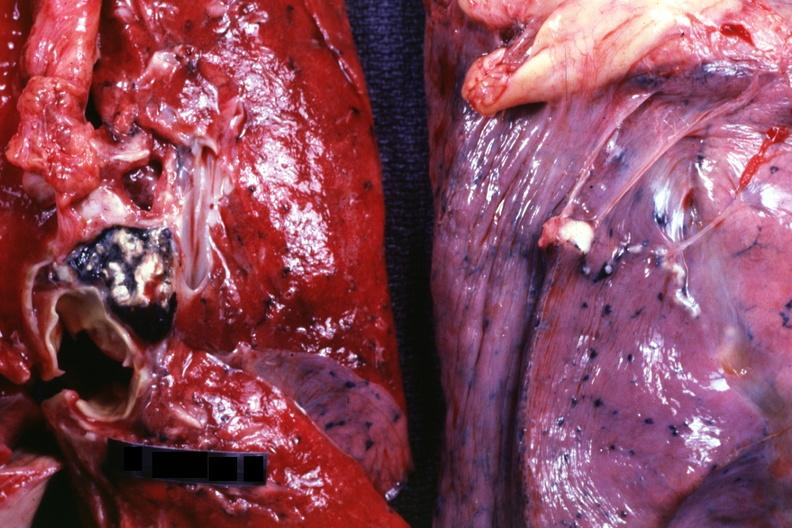what is present?
Answer the question using a single word or phrase. Lymph node 